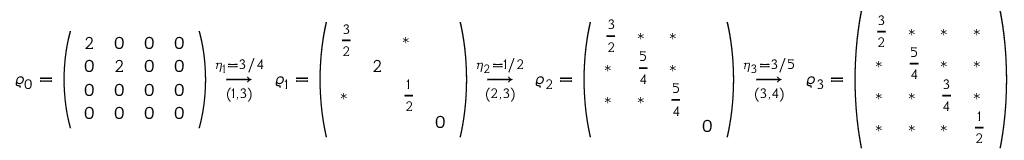Convert formula to latex. <formula><loc_0><loc_0><loc_500><loc_500>\varrho _ { 0 } = \left ( \begin{array} { l l l l } { 2 } & { 0 } & { 0 } & { 0 } \\ { 0 } & { 2 } & { 0 } & { 0 } \\ { 0 } & { 0 } & { 0 } & { 0 } \\ { 0 } & { 0 } & { 0 } & { 0 } \end{array} \right ) \overset { \eta _ { 1 } = 3 / 4 } { \underset { ( 1 , 3 ) } { \longrightarrow } } \, \varrho _ { 1 } = \left ( \begin{array} { l l l l } { \frac { 3 } { 2 } } & & { * } & \\ & { 2 } & & \\ { * } & & { \frac { 1 } { 2 } } & \\ & & & { 0 } \end{array} \right ) \overset { \eta _ { 2 } = 1 / 2 } { \underset { ( 2 , 3 ) } { \longrightarrow } } \, \varrho _ { 2 } = \left ( \begin{array} { l l l l } { \frac { 3 } { 2 } } & { * } & { * } & \\ { * } & { \frac { 5 } { 4 } } & { * } & \\ { * } & { * } & { \frac { 5 } { 4 } } & \\ & & & { 0 } \end{array} \right ) \overset { \eta _ { 3 } = 3 / 5 } { \underset { ( 3 , 4 ) } { \longrightarrow } } \, \varrho _ { 3 } = \left ( \begin{array} { l l l l } { \frac { 3 } { 2 } } & { * } & { * } & { * } \\ { * } & { \frac { 5 } { 4 } } & { * } & { * } \\ { * } & { * } & { \frac { 3 } { 4 } } & { * } \\ { * } & { * } & { * } & { \frac { 1 } { 2 } } \end{array} \right )</formula> 